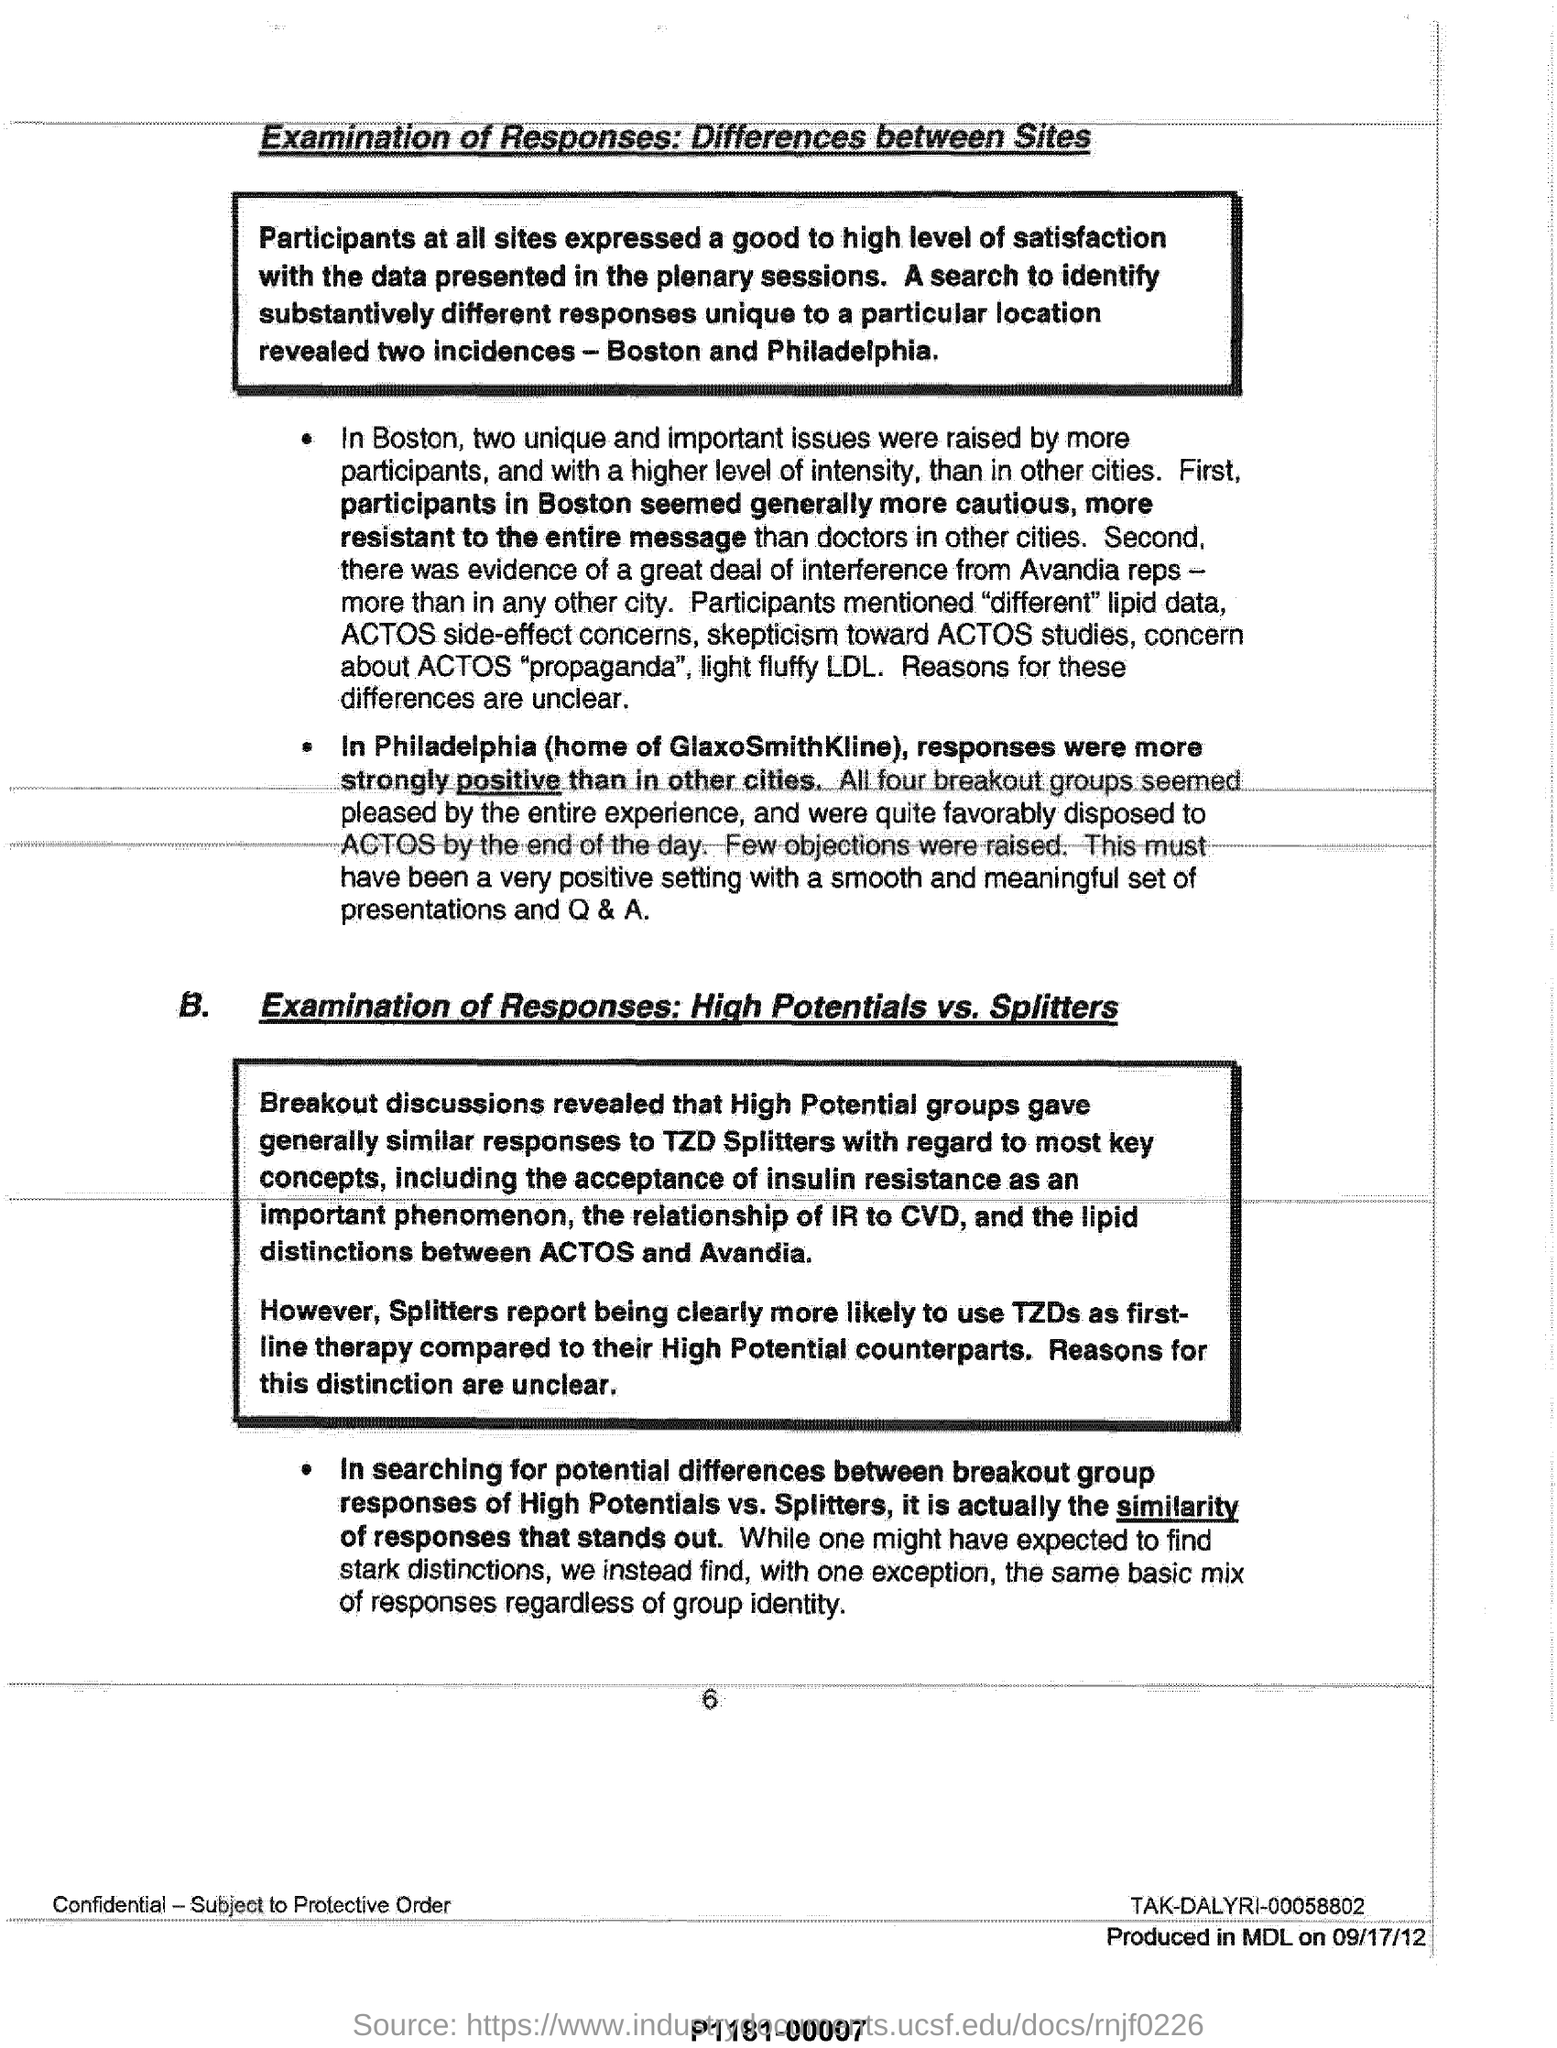Where participants seemed more cautious more resistant to the entire message?
Provide a succinct answer. In boston. Where were responses more strongly positive than in other cities?
Your answer should be compact. In Philadelphia. 